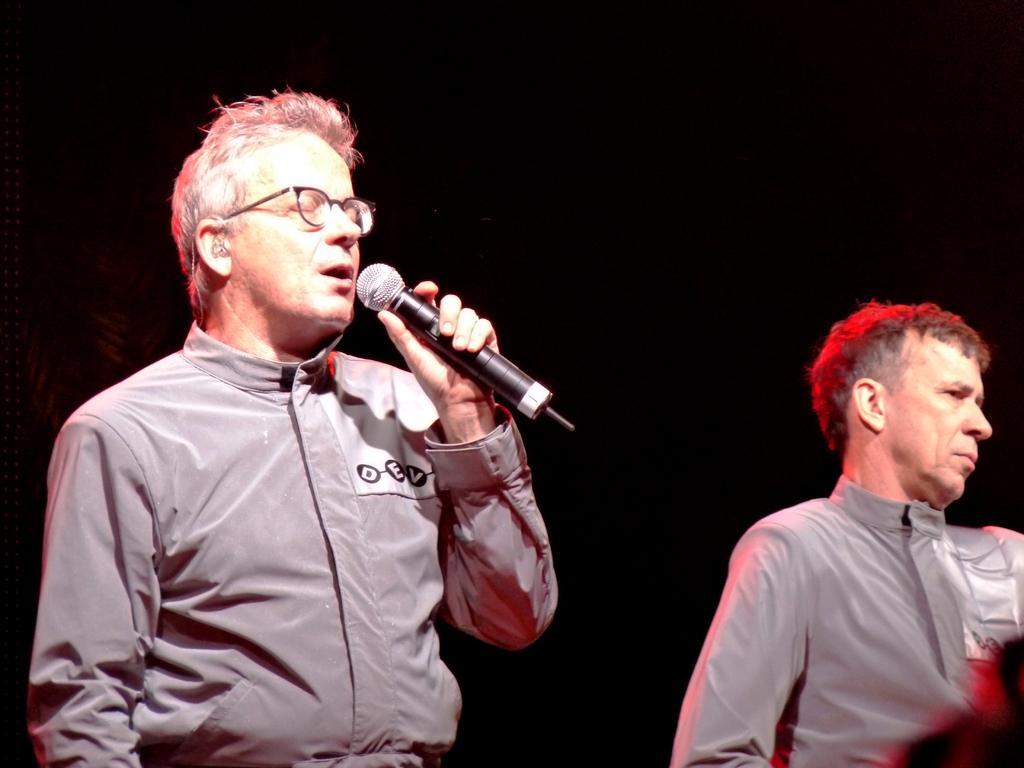Please provide a concise description of this image. In this picture we can see two men, a man on the left side is holding a microphone and speaking something, there is a dark background. 